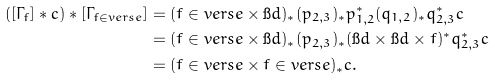Convert formula to latex. <formula><loc_0><loc_0><loc_500><loc_500>( [ \Gamma _ { f } ] * c ) * [ \Gamma _ { f \in v e r s e } ] & = ( f \in v e r s e \times \i d ) _ { * } ( p _ { 2 , 3 } ) _ { * } p _ { 1 , 2 } ^ { * } ( q _ { 1 , 2 } ) _ { * } q _ { 2 , 3 } ^ { * } c \\ & = ( f \in v e r s e \times \i d ) _ { * } ( p _ { 2 , 3 } ) _ { * } ( \i d \times \i d \times f ) ^ { * } q _ { 2 , 3 } ^ { * } c \\ & = ( f \in v e r s e \times f \in v e r s e ) _ { * } c .</formula> 